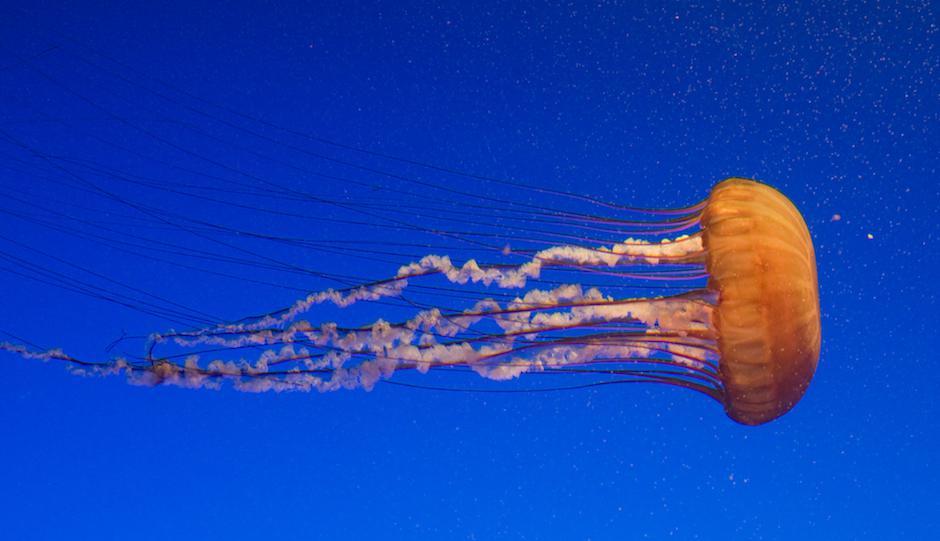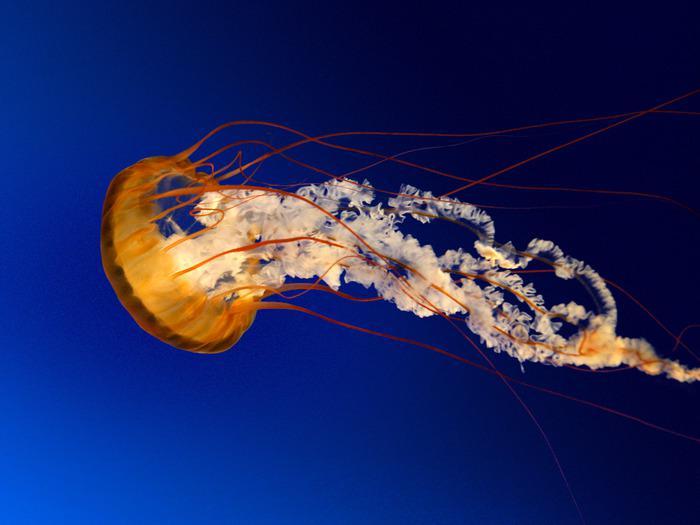The first image is the image on the left, the second image is the image on the right. Considering the images on both sides, is "in the image pair the jelly fish are facing each other" valid? Answer yes or no. Yes. The first image is the image on the left, the second image is the image on the right. Analyze the images presented: Is the assertion "Exactly two orange jellyfish are swimming through the water, one of them toward the right and the other one toward the left." valid? Answer yes or no. Yes. 